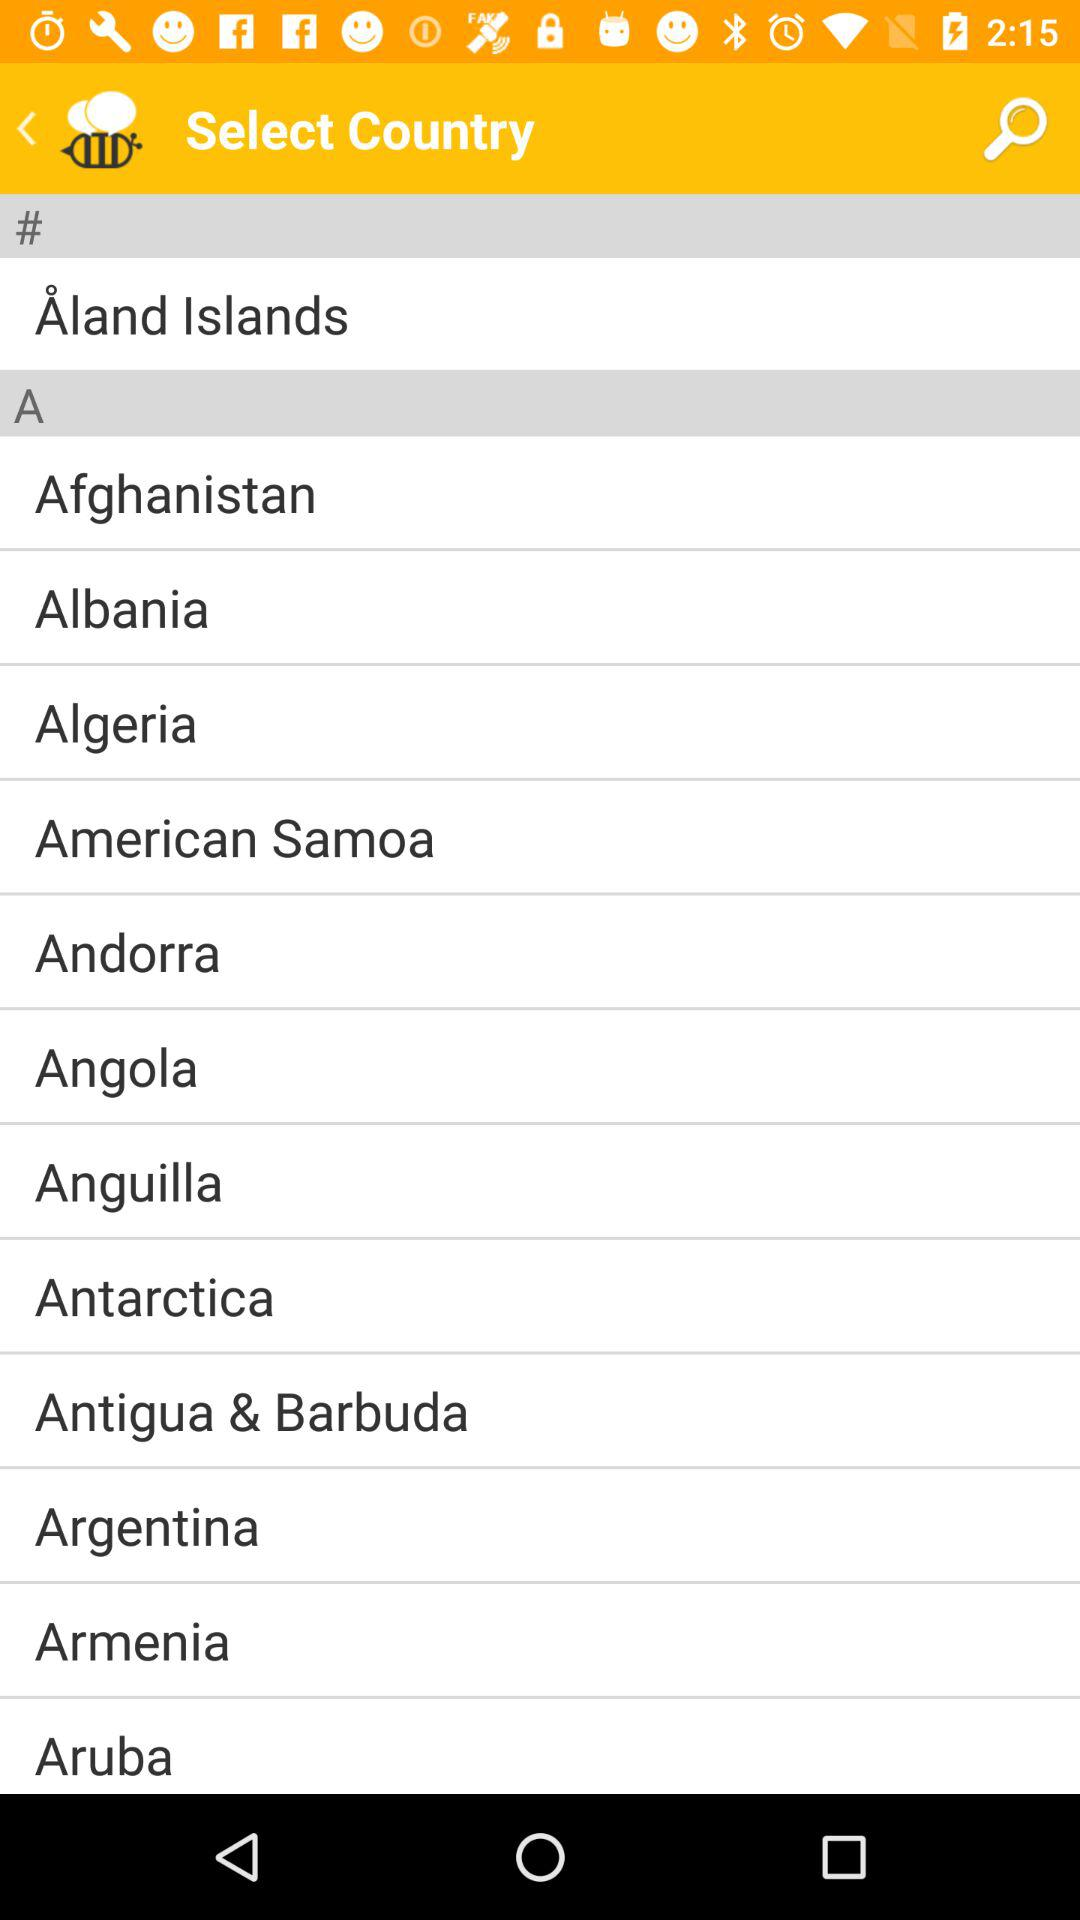What are the names of the countries starting with the letter "A"? The names of the countries mentioned under "A" are "Afghanistan", "Albania", "Algeria", "American Samoa", "Andorra", "Angola", "Anguilla", "Antarctica", "Antigua & Barbuda", "Argentina", "Armenia" and "Aruba". 